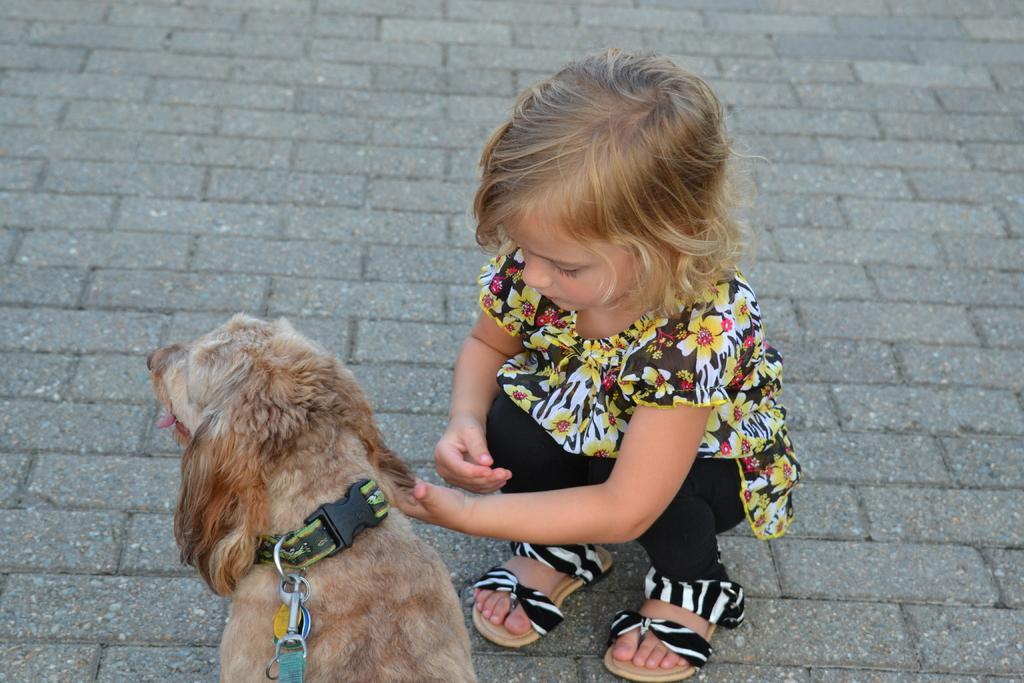How would you summarize this image in a sentence or two? In this picture, there is a girl, holding a dog on the floor. In the background there is a floor made up of blocks. 